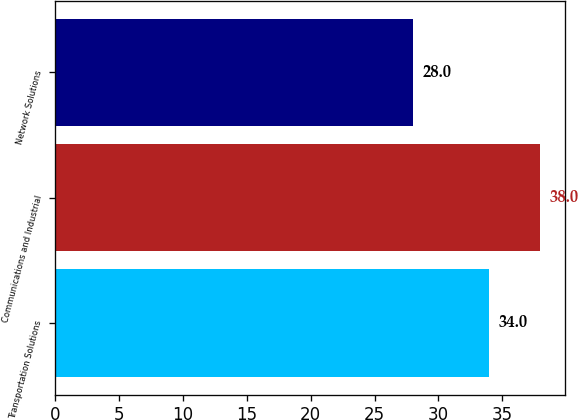Convert chart to OTSL. <chart><loc_0><loc_0><loc_500><loc_500><bar_chart><fcel>Transportation Solutions<fcel>Communications and Industrial<fcel>Network Solutions<nl><fcel>34<fcel>38<fcel>28<nl></chart> 